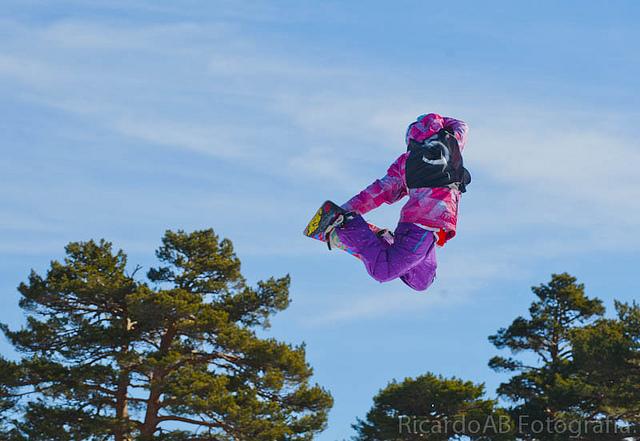What is the man of the tree on the left?
Write a very short answer. Pine. What kind of pattern is the jacket?
Short answer required. Abstract. What is the temperature outside where this picture is taken?
Quick response, please. Cold. What color is the snowsuit?
Answer briefly. Purple. Is the man doing a trick?
Answer briefly. Yes. What photographic angle was the picture taken?
Short answer required. Below. What color stands out?
Write a very short answer. Pink. 